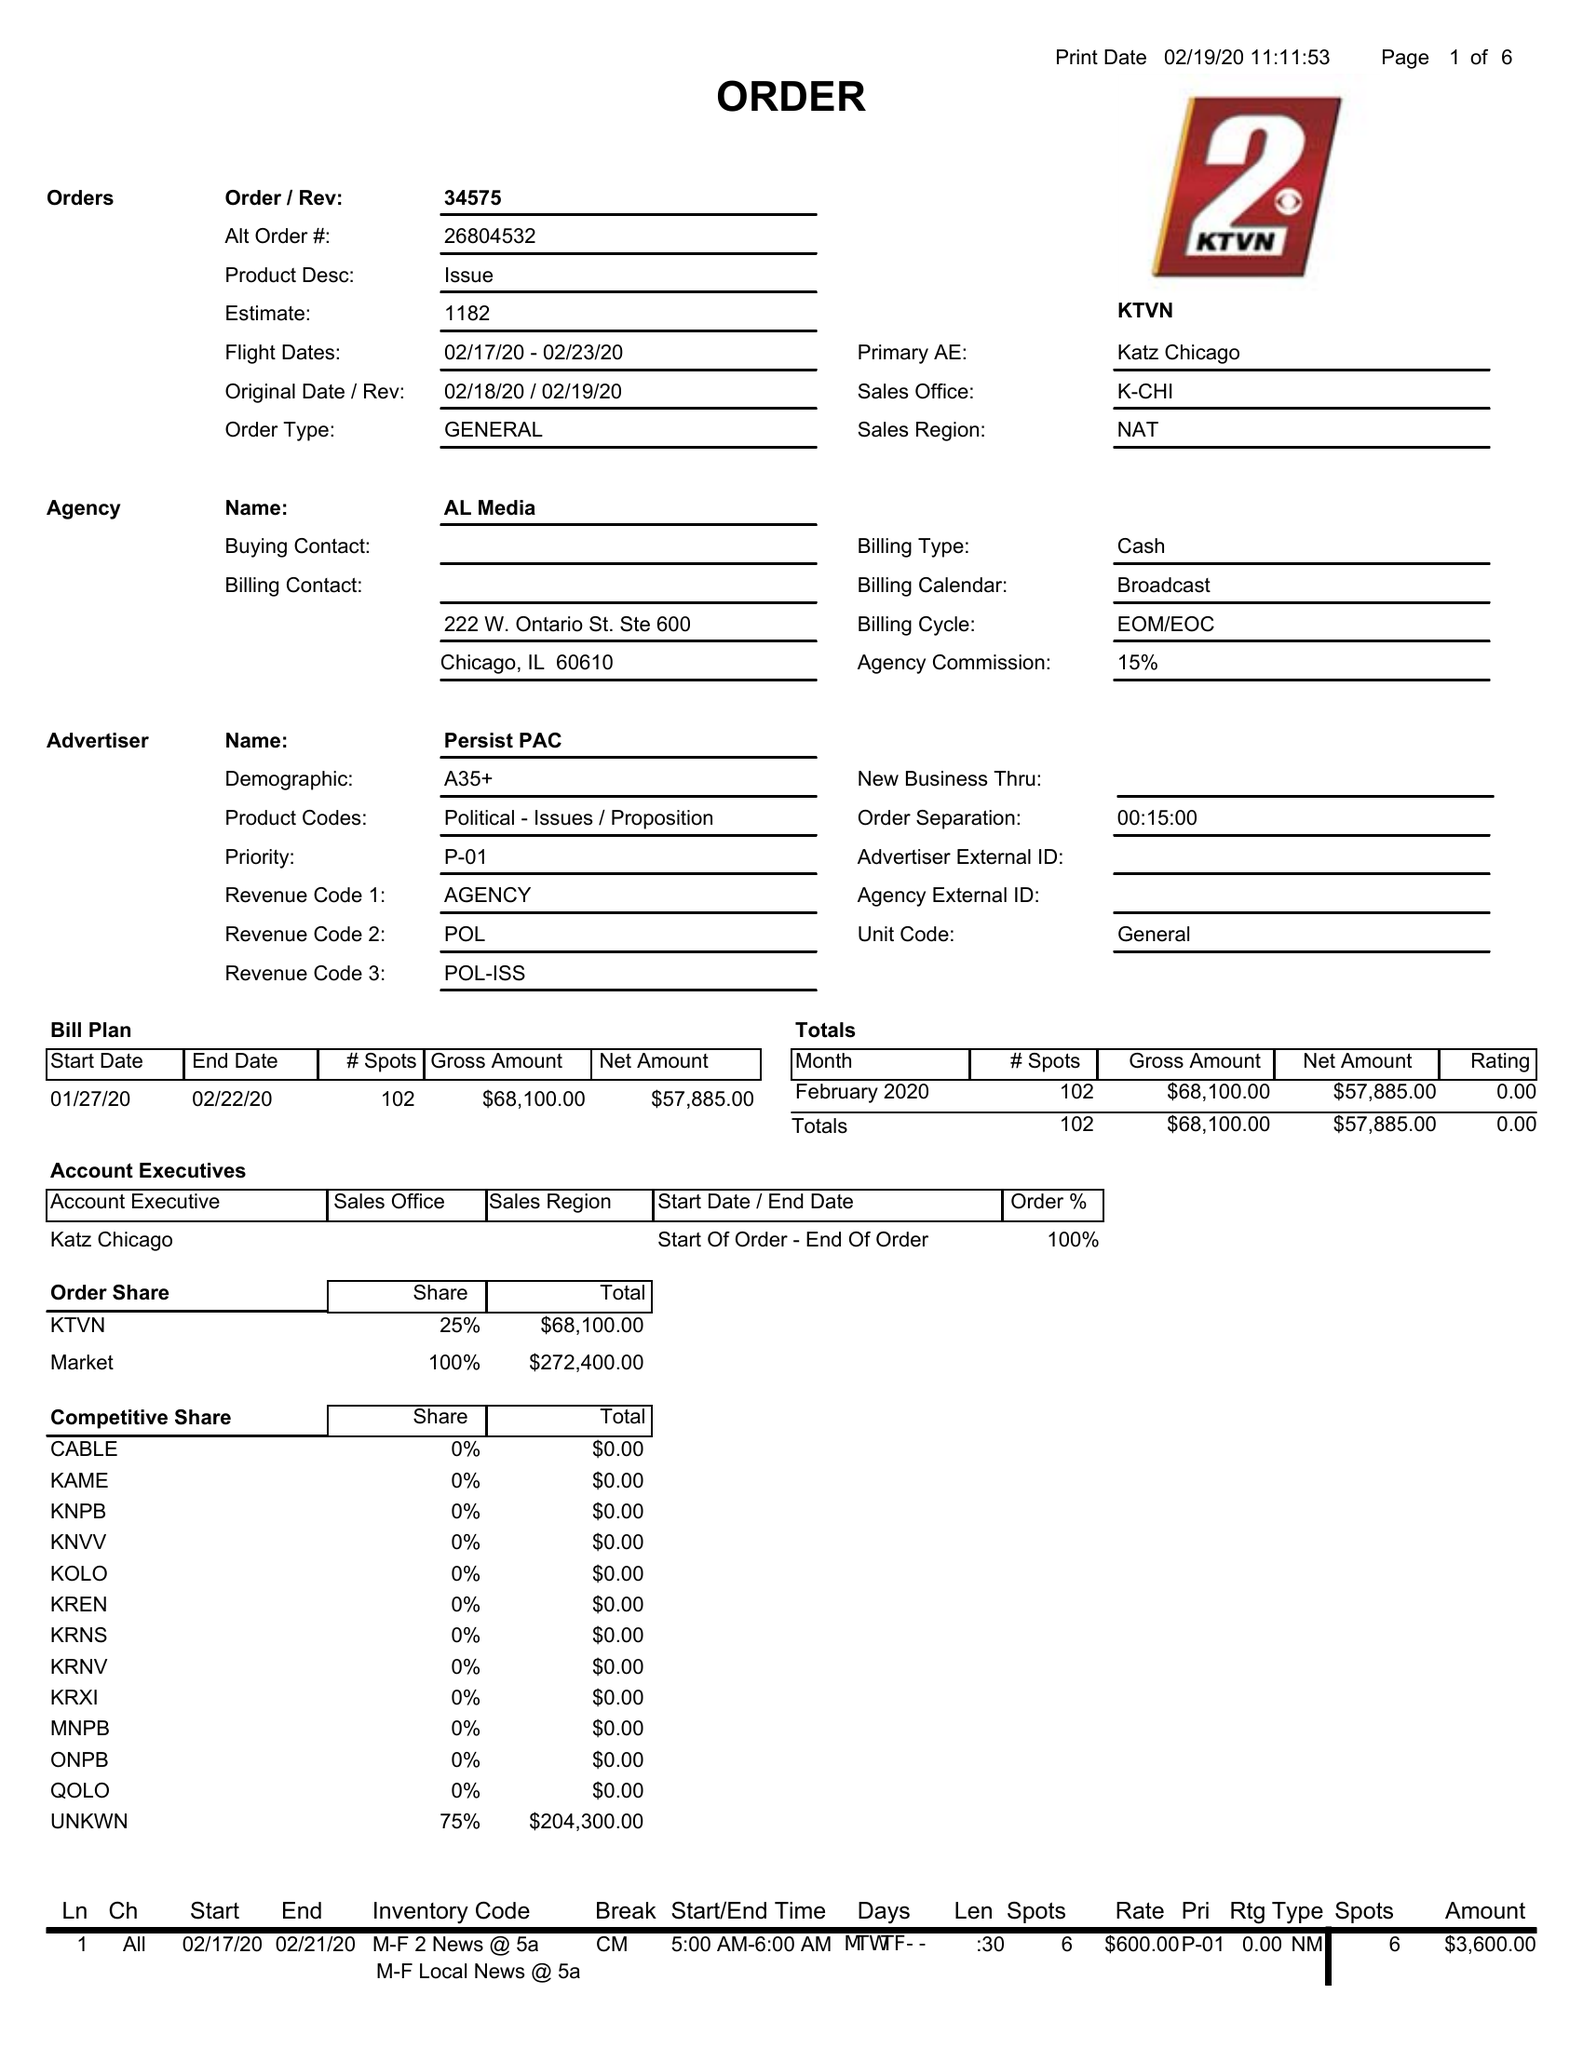What is the value for the flight_from?
Answer the question using a single word or phrase. 02/17/20 